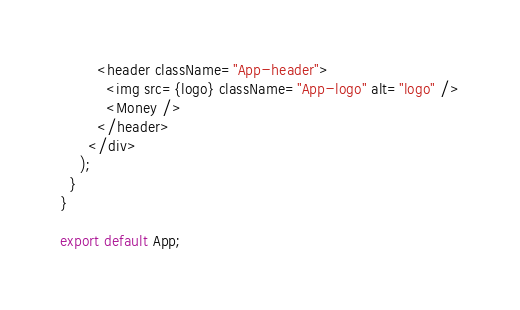<code> <loc_0><loc_0><loc_500><loc_500><_JavaScript_>        <header className="App-header">
          <img src={logo} className="App-logo" alt="logo" />
          <Money />
        </header>
      </div>
    );
  }
}

export default App;
</code> 